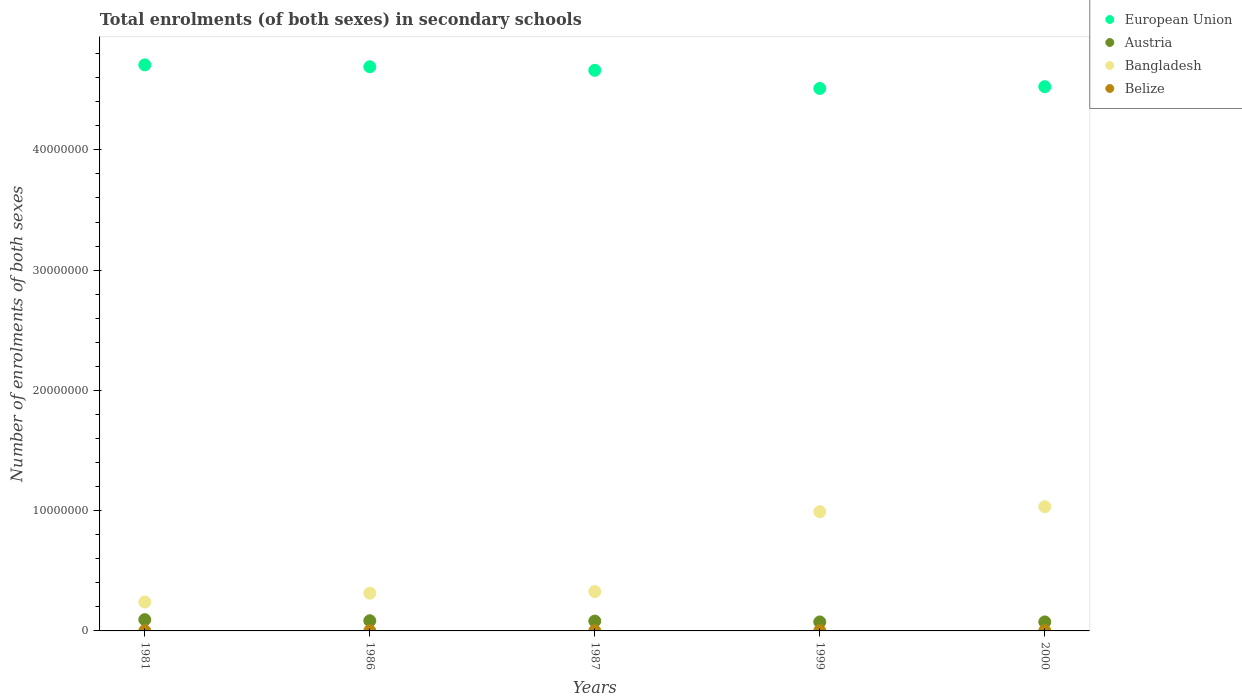How many different coloured dotlines are there?
Provide a short and direct response. 4. Is the number of dotlines equal to the number of legend labels?
Provide a succinct answer. Yes. What is the number of enrolments in secondary schools in Austria in 1987?
Offer a very short reply. 8.19e+05. Across all years, what is the maximum number of enrolments in secondary schools in Belize?
Give a very brief answer. 2.32e+04. Across all years, what is the minimum number of enrolments in secondary schools in Austria?
Offer a very short reply. 7.48e+05. In which year was the number of enrolments in secondary schools in Bangladesh maximum?
Offer a terse response. 2000. In which year was the number of enrolments in secondary schools in Belize minimum?
Your answer should be very brief. 1981. What is the total number of enrolments in secondary schools in Belize in the graph?
Your response must be concise. 8.73e+04. What is the difference between the number of enrolments in secondary schools in European Union in 1986 and that in 1999?
Keep it short and to the point. 1.80e+06. What is the difference between the number of enrolments in secondary schools in Belize in 1999 and the number of enrolments in secondary schools in Austria in 2000?
Ensure brevity in your answer.  -7.27e+05. What is the average number of enrolments in secondary schools in Bangladesh per year?
Provide a succinct answer. 5.81e+06. In the year 2000, what is the difference between the number of enrolments in secondary schools in Bangladesh and number of enrolments in secondary schools in Austria?
Offer a very short reply. 9.58e+06. What is the ratio of the number of enrolments in secondary schools in Austria in 1981 to that in 1999?
Offer a terse response. 1.25. Is the number of enrolments in secondary schools in Belize in 1981 less than that in 1986?
Give a very brief answer. Yes. What is the difference between the highest and the second highest number of enrolments in secondary schools in European Union?
Provide a short and direct response. 1.57e+05. What is the difference between the highest and the lowest number of enrolments in secondary schools in Belize?
Offer a terse response. 1.10e+04. Is the sum of the number of enrolments in secondary schools in European Union in 1987 and 2000 greater than the maximum number of enrolments in secondary schools in Bangladesh across all years?
Your answer should be compact. Yes. Does the number of enrolments in secondary schools in Belize monotonically increase over the years?
Provide a succinct answer. Yes. Is the number of enrolments in secondary schools in Bangladesh strictly less than the number of enrolments in secondary schools in European Union over the years?
Make the answer very short. Yes. How many years are there in the graph?
Offer a terse response. 5. What is the difference between two consecutive major ticks on the Y-axis?
Offer a very short reply. 1.00e+07. Does the graph contain any zero values?
Offer a terse response. No. Does the graph contain grids?
Make the answer very short. No. How are the legend labels stacked?
Offer a terse response. Vertical. What is the title of the graph?
Make the answer very short. Total enrolments (of both sexes) in secondary schools. What is the label or title of the X-axis?
Offer a terse response. Years. What is the label or title of the Y-axis?
Give a very brief answer. Number of enrolments of both sexes. What is the Number of enrolments of both sexes in European Union in 1981?
Provide a succinct answer. 4.71e+07. What is the Number of enrolments of both sexes in Austria in 1981?
Your answer should be very brief. 9.37e+05. What is the Number of enrolments of both sexes of Bangladesh in 1981?
Offer a very short reply. 2.41e+06. What is the Number of enrolments of both sexes of Belize in 1981?
Your response must be concise. 1.22e+04. What is the Number of enrolments of both sexes in European Union in 1986?
Ensure brevity in your answer.  4.69e+07. What is the Number of enrolments of both sexes in Austria in 1986?
Ensure brevity in your answer.  8.47e+05. What is the Number of enrolments of both sexes of Bangladesh in 1986?
Provide a short and direct response. 3.14e+06. What is the Number of enrolments of both sexes in Belize in 1986?
Your answer should be very brief. 1.46e+04. What is the Number of enrolments of both sexes of European Union in 1987?
Keep it short and to the point. 4.66e+07. What is the Number of enrolments of both sexes of Austria in 1987?
Keep it short and to the point. 8.19e+05. What is the Number of enrolments of both sexes of Bangladesh in 1987?
Offer a terse response. 3.27e+06. What is the Number of enrolments of both sexes in Belize in 1987?
Provide a short and direct response. 1.55e+04. What is the Number of enrolments of both sexes in European Union in 1999?
Your answer should be compact. 4.51e+07. What is the Number of enrolments of both sexes in Austria in 1999?
Offer a terse response. 7.48e+05. What is the Number of enrolments of both sexes of Bangladesh in 1999?
Provide a succinct answer. 9.91e+06. What is the Number of enrolments of both sexes in Belize in 1999?
Your response must be concise. 2.17e+04. What is the Number of enrolments of both sexes of European Union in 2000?
Provide a succinct answer. 4.53e+07. What is the Number of enrolments of both sexes in Austria in 2000?
Your response must be concise. 7.49e+05. What is the Number of enrolments of both sexes in Bangladesh in 2000?
Offer a very short reply. 1.03e+07. What is the Number of enrolments of both sexes of Belize in 2000?
Offer a very short reply. 2.32e+04. Across all years, what is the maximum Number of enrolments of both sexes of European Union?
Provide a succinct answer. 4.71e+07. Across all years, what is the maximum Number of enrolments of both sexes of Austria?
Ensure brevity in your answer.  9.37e+05. Across all years, what is the maximum Number of enrolments of both sexes of Bangladesh?
Offer a very short reply. 1.03e+07. Across all years, what is the maximum Number of enrolments of both sexes in Belize?
Offer a very short reply. 2.32e+04. Across all years, what is the minimum Number of enrolments of both sexes of European Union?
Your answer should be very brief. 4.51e+07. Across all years, what is the minimum Number of enrolments of both sexes in Austria?
Your answer should be compact. 7.48e+05. Across all years, what is the minimum Number of enrolments of both sexes of Bangladesh?
Provide a succinct answer. 2.41e+06. Across all years, what is the minimum Number of enrolments of both sexes in Belize?
Ensure brevity in your answer.  1.22e+04. What is the total Number of enrolments of both sexes of European Union in the graph?
Provide a short and direct response. 2.31e+08. What is the total Number of enrolments of both sexes of Austria in the graph?
Keep it short and to the point. 4.10e+06. What is the total Number of enrolments of both sexes of Bangladesh in the graph?
Provide a succinct answer. 2.91e+07. What is the total Number of enrolments of both sexes in Belize in the graph?
Offer a very short reply. 8.73e+04. What is the difference between the Number of enrolments of both sexes of European Union in 1981 and that in 1986?
Provide a succinct answer. 1.57e+05. What is the difference between the Number of enrolments of both sexes of Austria in 1981 and that in 1986?
Keep it short and to the point. 9.03e+04. What is the difference between the Number of enrolments of both sexes of Bangladesh in 1981 and that in 1986?
Ensure brevity in your answer.  -7.29e+05. What is the difference between the Number of enrolments of both sexes in Belize in 1981 and that in 1986?
Keep it short and to the point. -2399. What is the difference between the Number of enrolments of both sexes of European Union in 1981 and that in 1987?
Offer a terse response. 4.52e+05. What is the difference between the Number of enrolments of both sexes of Austria in 1981 and that in 1987?
Provide a short and direct response. 1.19e+05. What is the difference between the Number of enrolments of both sexes in Bangladesh in 1981 and that in 1987?
Your response must be concise. -8.65e+05. What is the difference between the Number of enrolments of both sexes in Belize in 1981 and that in 1987?
Keep it short and to the point. -3257. What is the difference between the Number of enrolments of both sexes of European Union in 1981 and that in 1999?
Keep it short and to the point. 1.96e+06. What is the difference between the Number of enrolments of both sexes in Austria in 1981 and that in 1999?
Your response must be concise. 1.90e+05. What is the difference between the Number of enrolments of both sexes in Bangladesh in 1981 and that in 1999?
Provide a succinct answer. -7.50e+06. What is the difference between the Number of enrolments of both sexes of Belize in 1981 and that in 1999?
Offer a terse response. -9411. What is the difference between the Number of enrolments of both sexes of European Union in 1981 and that in 2000?
Provide a succinct answer. 1.81e+06. What is the difference between the Number of enrolments of both sexes of Austria in 1981 and that in 2000?
Give a very brief answer. 1.89e+05. What is the difference between the Number of enrolments of both sexes of Bangladesh in 1981 and that in 2000?
Your answer should be very brief. -7.92e+06. What is the difference between the Number of enrolments of both sexes in Belize in 1981 and that in 2000?
Ensure brevity in your answer.  -1.10e+04. What is the difference between the Number of enrolments of both sexes of European Union in 1986 and that in 1987?
Make the answer very short. 2.95e+05. What is the difference between the Number of enrolments of both sexes of Austria in 1986 and that in 1987?
Your response must be concise. 2.83e+04. What is the difference between the Number of enrolments of both sexes in Bangladesh in 1986 and that in 1987?
Keep it short and to the point. -1.36e+05. What is the difference between the Number of enrolments of both sexes of Belize in 1986 and that in 1987?
Provide a short and direct response. -858. What is the difference between the Number of enrolments of both sexes of European Union in 1986 and that in 1999?
Your answer should be compact. 1.80e+06. What is the difference between the Number of enrolments of both sexes in Austria in 1986 and that in 1999?
Provide a short and direct response. 9.95e+04. What is the difference between the Number of enrolments of both sexes of Bangladesh in 1986 and that in 1999?
Your answer should be very brief. -6.78e+06. What is the difference between the Number of enrolments of both sexes of Belize in 1986 and that in 1999?
Give a very brief answer. -7012. What is the difference between the Number of enrolments of both sexes of European Union in 1986 and that in 2000?
Your answer should be compact. 1.66e+06. What is the difference between the Number of enrolments of both sexes in Austria in 1986 and that in 2000?
Provide a short and direct response. 9.85e+04. What is the difference between the Number of enrolments of both sexes of Bangladesh in 1986 and that in 2000?
Offer a terse response. -7.19e+06. What is the difference between the Number of enrolments of both sexes of Belize in 1986 and that in 2000?
Your response must be concise. -8588. What is the difference between the Number of enrolments of both sexes in European Union in 1987 and that in 1999?
Offer a terse response. 1.51e+06. What is the difference between the Number of enrolments of both sexes in Austria in 1987 and that in 1999?
Your response must be concise. 7.12e+04. What is the difference between the Number of enrolments of both sexes in Bangladesh in 1987 and that in 1999?
Give a very brief answer. -6.64e+06. What is the difference between the Number of enrolments of both sexes in Belize in 1987 and that in 1999?
Make the answer very short. -6154. What is the difference between the Number of enrolments of both sexes of European Union in 1987 and that in 2000?
Your answer should be very brief. 1.36e+06. What is the difference between the Number of enrolments of both sexes of Austria in 1987 and that in 2000?
Your answer should be very brief. 7.02e+04. What is the difference between the Number of enrolments of both sexes of Bangladesh in 1987 and that in 2000?
Your answer should be compact. -7.06e+06. What is the difference between the Number of enrolments of both sexes of Belize in 1987 and that in 2000?
Your answer should be compact. -7730. What is the difference between the Number of enrolments of both sexes in European Union in 1999 and that in 2000?
Ensure brevity in your answer.  -1.47e+05. What is the difference between the Number of enrolments of both sexes of Austria in 1999 and that in 2000?
Offer a terse response. -978. What is the difference between the Number of enrolments of both sexes in Bangladesh in 1999 and that in 2000?
Make the answer very short. -4.17e+05. What is the difference between the Number of enrolments of both sexes in Belize in 1999 and that in 2000?
Offer a very short reply. -1576. What is the difference between the Number of enrolments of both sexes in European Union in 1981 and the Number of enrolments of both sexes in Austria in 1986?
Make the answer very short. 4.62e+07. What is the difference between the Number of enrolments of both sexes of European Union in 1981 and the Number of enrolments of both sexes of Bangladesh in 1986?
Your answer should be compact. 4.39e+07. What is the difference between the Number of enrolments of both sexes in European Union in 1981 and the Number of enrolments of both sexes in Belize in 1986?
Provide a succinct answer. 4.71e+07. What is the difference between the Number of enrolments of both sexes in Austria in 1981 and the Number of enrolments of both sexes in Bangladesh in 1986?
Your answer should be compact. -2.20e+06. What is the difference between the Number of enrolments of both sexes in Austria in 1981 and the Number of enrolments of both sexes in Belize in 1986?
Provide a short and direct response. 9.23e+05. What is the difference between the Number of enrolments of both sexes in Bangladesh in 1981 and the Number of enrolments of both sexes in Belize in 1986?
Your answer should be very brief. 2.39e+06. What is the difference between the Number of enrolments of both sexes of European Union in 1981 and the Number of enrolments of both sexes of Austria in 1987?
Offer a very short reply. 4.63e+07. What is the difference between the Number of enrolments of both sexes in European Union in 1981 and the Number of enrolments of both sexes in Bangladesh in 1987?
Keep it short and to the point. 4.38e+07. What is the difference between the Number of enrolments of both sexes in European Union in 1981 and the Number of enrolments of both sexes in Belize in 1987?
Offer a terse response. 4.71e+07. What is the difference between the Number of enrolments of both sexes in Austria in 1981 and the Number of enrolments of both sexes in Bangladesh in 1987?
Offer a terse response. -2.34e+06. What is the difference between the Number of enrolments of both sexes of Austria in 1981 and the Number of enrolments of both sexes of Belize in 1987?
Your response must be concise. 9.22e+05. What is the difference between the Number of enrolments of both sexes of Bangladesh in 1981 and the Number of enrolments of both sexes of Belize in 1987?
Provide a short and direct response. 2.39e+06. What is the difference between the Number of enrolments of both sexes in European Union in 1981 and the Number of enrolments of both sexes in Austria in 1999?
Your answer should be compact. 4.63e+07. What is the difference between the Number of enrolments of both sexes in European Union in 1981 and the Number of enrolments of both sexes in Bangladesh in 1999?
Your response must be concise. 3.72e+07. What is the difference between the Number of enrolments of both sexes in European Union in 1981 and the Number of enrolments of both sexes in Belize in 1999?
Your answer should be compact. 4.70e+07. What is the difference between the Number of enrolments of both sexes in Austria in 1981 and the Number of enrolments of both sexes in Bangladesh in 1999?
Your answer should be very brief. -8.97e+06. What is the difference between the Number of enrolments of both sexes in Austria in 1981 and the Number of enrolments of both sexes in Belize in 1999?
Offer a very short reply. 9.16e+05. What is the difference between the Number of enrolments of both sexes of Bangladesh in 1981 and the Number of enrolments of both sexes of Belize in 1999?
Your response must be concise. 2.39e+06. What is the difference between the Number of enrolments of both sexes in European Union in 1981 and the Number of enrolments of both sexes in Austria in 2000?
Provide a succinct answer. 4.63e+07. What is the difference between the Number of enrolments of both sexes in European Union in 1981 and the Number of enrolments of both sexes in Bangladesh in 2000?
Give a very brief answer. 3.67e+07. What is the difference between the Number of enrolments of both sexes of European Union in 1981 and the Number of enrolments of both sexes of Belize in 2000?
Ensure brevity in your answer.  4.70e+07. What is the difference between the Number of enrolments of both sexes in Austria in 1981 and the Number of enrolments of both sexes in Bangladesh in 2000?
Your response must be concise. -9.39e+06. What is the difference between the Number of enrolments of both sexes in Austria in 1981 and the Number of enrolments of both sexes in Belize in 2000?
Your answer should be compact. 9.14e+05. What is the difference between the Number of enrolments of both sexes in Bangladesh in 1981 and the Number of enrolments of both sexes in Belize in 2000?
Offer a very short reply. 2.38e+06. What is the difference between the Number of enrolments of both sexes of European Union in 1986 and the Number of enrolments of both sexes of Austria in 1987?
Give a very brief answer. 4.61e+07. What is the difference between the Number of enrolments of both sexes of European Union in 1986 and the Number of enrolments of both sexes of Bangladesh in 1987?
Your answer should be very brief. 4.36e+07. What is the difference between the Number of enrolments of both sexes of European Union in 1986 and the Number of enrolments of both sexes of Belize in 1987?
Your response must be concise. 4.69e+07. What is the difference between the Number of enrolments of both sexes of Austria in 1986 and the Number of enrolments of both sexes of Bangladesh in 1987?
Provide a succinct answer. -2.43e+06. What is the difference between the Number of enrolments of both sexes in Austria in 1986 and the Number of enrolments of both sexes in Belize in 1987?
Your answer should be compact. 8.32e+05. What is the difference between the Number of enrolments of both sexes in Bangladesh in 1986 and the Number of enrolments of both sexes in Belize in 1987?
Your answer should be compact. 3.12e+06. What is the difference between the Number of enrolments of both sexes in European Union in 1986 and the Number of enrolments of both sexes in Austria in 1999?
Ensure brevity in your answer.  4.62e+07. What is the difference between the Number of enrolments of both sexes of European Union in 1986 and the Number of enrolments of both sexes of Bangladesh in 1999?
Ensure brevity in your answer.  3.70e+07. What is the difference between the Number of enrolments of both sexes in European Union in 1986 and the Number of enrolments of both sexes in Belize in 1999?
Your answer should be very brief. 4.69e+07. What is the difference between the Number of enrolments of both sexes of Austria in 1986 and the Number of enrolments of both sexes of Bangladesh in 1999?
Your answer should be very brief. -9.07e+06. What is the difference between the Number of enrolments of both sexes of Austria in 1986 and the Number of enrolments of both sexes of Belize in 1999?
Offer a very short reply. 8.26e+05. What is the difference between the Number of enrolments of both sexes in Bangladesh in 1986 and the Number of enrolments of both sexes in Belize in 1999?
Ensure brevity in your answer.  3.11e+06. What is the difference between the Number of enrolments of both sexes in European Union in 1986 and the Number of enrolments of both sexes in Austria in 2000?
Give a very brief answer. 4.62e+07. What is the difference between the Number of enrolments of both sexes in European Union in 1986 and the Number of enrolments of both sexes in Bangladesh in 2000?
Provide a short and direct response. 3.66e+07. What is the difference between the Number of enrolments of both sexes of European Union in 1986 and the Number of enrolments of both sexes of Belize in 2000?
Keep it short and to the point. 4.69e+07. What is the difference between the Number of enrolments of both sexes in Austria in 1986 and the Number of enrolments of both sexes in Bangladesh in 2000?
Your response must be concise. -9.48e+06. What is the difference between the Number of enrolments of both sexes of Austria in 1986 and the Number of enrolments of both sexes of Belize in 2000?
Make the answer very short. 8.24e+05. What is the difference between the Number of enrolments of both sexes in Bangladesh in 1986 and the Number of enrolments of both sexes in Belize in 2000?
Offer a very short reply. 3.11e+06. What is the difference between the Number of enrolments of both sexes of European Union in 1987 and the Number of enrolments of both sexes of Austria in 1999?
Provide a succinct answer. 4.59e+07. What is the difference between the Number of enrolments of both sexes in European Union in 1987 and the Number of enrolments of both sexes in Bangladesh in 1999?
Your response must be concise. 3.67e+07. What is the difference between the Number of enrolments of both sexes of European Union in 1987 and the Number of enrolments of both sexes of Belize in 1999?
Give a very brief answer. 4.66e+07. What is the difference between the Number of enrolments of both sexes in Austria in 1987 and the Number of enrolments of both sexes in Bangladesh in 1999?
Your response must be concise. -9.09e+06. What is the difference between the Number of enrolments of both sexes of Austria in 1987 and the Number of enrolments of both sexes of Belize in 1999?
Give a very brief answer. 7.97e+05. What is the difference between the Number of enrolments of both sexes in Bangladesh in 1987 and the Number of enrolments of both sexes in Belize in 1999?
Your response must be concise. 3.25e+06. What is the difference between the Number of enrolments of both sexes of European Union in 1987 and the Number of enrolments of both sexes of Austria in 2000?
Provide a short and direct response. 4.59e+07. What is the difference between the Number of enrolments of both sexes in European Union in 1987 and the Number of enrolments of both sexes in Bangladesh in 2000?
Give a very brief answer. 3.63e+07. What is the difference between the Number of enrolments of both sexes in European Union in 1987 and the Number of enrolments of both sexes in Belize in 2000?
Make the answer very short. 4.66e+07. What is the difference between the Number of enrolments of both sexes in Austria in 1987 and the Number of enrolments of both sexes in Bangladesh in 2000?
Your response must be concise. -9.51e+06. What is the difference between the Number of enrolments of both sexes of Austria in 1987 and the Number of enrolments of both sexes of Belize in 2000?
Your answer should be compact. 7.96e+05. What is the difference between the Number of enrolments of both sexes of Bangladesh in 1987 and the Number of enrolments of both sexes of Belize in 2000?
Provide a short and direct response. 3.25e+06. What is the difference between the Number of enrolments of both sexes of European Union in 1999 and the Number of enrolments of both sexes of Austria in 2000?
Offer a terse response. 4.44e+07. What is the difference between the Number of enrolments of both sexes in European Union in 1999 and the Number of enrolments of both sexes in Bangladesh in 2000?
Your answer should be very brief. 3.48e+07. What is the difference between the Number of enrolments of both sexes in European Union in 1999 and the Number of enrolments of both sexes in Belize in 2000?
Make the answer very short. 4.51e+07. What is the difference between the Number of enrolments of both sexes of Austria in 1999 and the Number of enrolments of both sexes of Bangladesh in 2000?
Your answer should be very brief. -9.58e+06. What is the difference between the Number of enrolments of both sexes of Austria in 1999 and the Number of enrolments of both sexes of Belize in 2000?
Provide a succinct answer. 7.24e+05. What is the difference between the Number of enrolments of both sexes of Bangladesh in 1999 and the Number of enrolments of both sexes of Belize in 2000?
Give a very brief answer. 9.89e+06. What is the average Number of enrolments of both sexes in European Union per year?
Ensure brevity in your answer.  4.62e+07. What is the average Number of enrolments of both sexes in Austria per year?
Keep it short and to the point. 8.20e+05. What is the average Number of enrolments of both sexes of Bangladesh per year?
Your answer should be very brief. 5.81e+06. What is the average Number of enrolments of both sexes of Belize per year?
Keep it short and to the point. 1.75e+04. In the year 1981, what is the difference between the Number of enrolments of both sexes in European Union and Number of enrolments of both sexes in Austria?
Provide a short and direct response. 4.61e+07. In the year 1981, what is the difference between the Number of enrolments of both sexes in European Union and Number of enrolments of both sexes in Bangladesh?
Keep it short and to the point. 4.47e+07. In the year 1981, what is the difference between the Number of enrolments of both sexes of European Union and Number of enrolments of both sexes of Belize?
Your response must be concise. 4.71e+07. In the year 1981, what is the difference between the Number of enrolments of both sexes in Austria and Number of enrolments of both sexes in Bangladesh?
Keep it short and to the point. -1.47e+06. In the year 1981, what is the difference between the Number of enrolments of both sexes in Austria and Number of enrolments of both sexes in Belize?
Offer a very short reply. 9.25e+05. In the year 1981, what is the difference between the Number of enrolments of both sexes of Bangladesh and Number of enrolments of both sexes of Belize?
Your response must be concise. 2.40e+06. In the year 1986, what is the difference between the Number of enrolments of both sexes of European Union and Number of enrolments of both sexes of Austria?
Your answer should be compact. 4.61e+07. In the year 1986, what is the difference between the Number of enrolments of both sexes of European Union and Number of enrolments of both sexes of Bangladesh?
Offer a very short reply. 4.38e+07. In the year 1986, what is the difference between the Number of enrolments of both sexes in European Union and Number of enrolments of both sexes in Belize?
Offer a terse response. 4.69e+07. In the year 1986, what is the difference between the Number of enrolments of both sexes in Austria and Number of enrolments of both sexes in Bangladesh?
Ensure brevity in your answer.  -2.29e+06. In the year 1986, what is the difference between the Number of enrolments of both sexes in Austria and Number of enrolments of both sexes in Belize?
Offer a terse response. 8.33e+05. In the year 1986, what is the difference between the Number of enrolments of both sexes in Bangladesh and Number of enrolments of both sexes in Belize?
Make the answer very short. 3.12e+06. In the year 1987, what is the difference between the Number of enrolments of both sexes in European Union and Number of enrolments of both sexes in Austria?
Your response must be concise. 4.58e+07. In the year 1987, what is the difference between the Number of enrolments of both sexes of European Union and Number of enrolments of both sexes of Bangladesh?
Ensure brevity in your answer.  4.33e+07. In the year 1987, what is the difference between the Number of enrolments of both sexes in European Union and Number of enrolments of both sexes in Belize?
Your response must be concise. 4.66e+07. In the year 1987, what is the difference between the Number of enrolments of both sexes in Austria and Number of enrolments of both sexes in Bangladesh?
Offer a very short reply. -2.45e+06. In the year 1987, what is the difference between the Number of enrolments of both sexes in Austria and Number of enrolments of both sexes in Belize?
Your answer should be very brief. 8.03e+05. In the year 1987, what is the difference between the Number of enrolments of both sexes in Bangladesh and Number of enrolments of both sexes in Belize?
Your answer should be compact. 3.26e+06. In the year 1999, what is the difference between the Number of enrolments of both sexes in European Union and Number of enrolments of both sexes in Austria?
Give a very brief answer. 4.44e+07. In the year 1999, what is the difference between the Number of enrolments of both sexes of European Union and Number of enrolments of both sexes of Bangladesh?
Offer a terse response. 3.52e+07. In the year 1999, what is the difference between the Number of enrolments of both sexes of European Union and Number of enrolments of both sexes of Belize?
Offer a terse response. 4.51e+07. In the year 1999, what is the difference between the Number of enrolments of both sexes in Austria and Number of enrolments of both sexes in Bangladesh?
Provide a short and direct response. -9.16e+06. In the year 1999, what is the difference between the Number of enrolments of both sexes of Austria and Number of enrolments of both sexes of Belize?
Offer a terse response. 7.26e+05. In the year 1999, what is the difference between the Number of enrolments of both sexes in Bangladesh and Number of enrolments of both sexes in Belize?
Make the answer very short. 9.89e+06. In the year 2000, what is the difference between the Number of enrolments of both sexes of European Union and Number of enrolments of both sexes of Austria?
Provide a succinct answer. 4.45e+07. In the year 2000, what is the difference between the Number of enrolments of both sexes of European Union and Number of enrolments of both sexes of Bangladesh?
Offer a terse response. 3.49e+07. In the year 2000, what is the difference between the Number of enrolments of both sexes of European Union and Number of enrolments of both sexes of Belize?
Offer a very short reply. 4.52e+07. In the year 2000, what is the difference between the Number of enrolments of both sexes of Austria and Number of enrolments of both sexes of Bangladesh?
Provide a succinct answer. -9.58e+06. In the year 2000, what is the difference between the Number of enrolments of both sexes of Austria and Number of enrolments of both sexes of Belize?
Ensure brevity in your answer.  7.25e+05. In the year 2000, what is the difference between the Number of enrolments of both sexes in Bangladesh and Number of enrolments of both sexes in Belize?
Give a very brief answer. 1.03e+07. What is the ratio of the Number of enrolments of both sexes of Austria in 1981 to that in 1986?
Your answer should be compact. 1.11. What is the ratio of the Number of enrolments of both sexes of Bangladesh in 1981 to that in 1986?
Offer a terse response. 0.77. What is the ratio of the Number of enrolments of both sexes in Belize in 1981 to that in 1986?
Your answer should be compact. 0.84. What is the ratio of the Number of enrolments of both sexes of European Union in 1981 to that in 1987?
Make the answer very short. 1.01. What is the ratio of the Number of enrolments of both sexes in Austria in 1981 to that in 1987?
Provide a succinct answer. 1.14. What is the ratio of the Number of enrolments of both sexes in Bangladesh in 1981 to that in 1987?
Give a very brief answer. 0.74. What is the ratio of the Number of enrolments of both sexes of Belize in 1981 to that in 1987?
Keep it short and to the point. 0.79. What is the ratio of the Number of enrolments of both sexes in European Union in 1981 to that in 1999?
Provide a succinct answer. 1.04. What is the ratio of the Number of enrolments of both sexes of Austria in 1981 to that in 1999?
Your answer should be compact. 1.25. What is the ratio of the Number of enrolments of both sexes of Bangladesh in 1981 to that in 1999?
Make the answer very short. 0.24. What is the ratio of the Number of enrolments of both sexes in Belize in 1981 to that in 1999?
Offer a terse response. 0.57. What is the ratio of the Number of enrolments of both sexes in European Union in 1981 to that in 2000?
Offer a terse response. 1.04. What is the ratio of the Number of enrolments of both sexes of Austria in 1981 to that in 2000?
Make the answer very short. 1.25. What is the ratio of the Number of enrolments of both sexes of Bangladesh in 1981 to that in 2000?
Offer a terse response. 0.23. What is the ratio of the Number of enrolments of both sexes in Belize in 1981 to that in 2000?
Your response must be concise. 0.53. What is the ratio of the Number of enrolments of both sexes of European Union in 1986 to that in 1987?
Your answer should be very brief. 1.01. What is the ratio of the Number of enrolments of both sexes in Austria in 1986 to that in 1987?
Your response must be concise. 1.03. What is the ratio of the Number of enrolments of both sexes of Bangladesh in 1986 to that in 1987?
Keep it short and to the point. 0.96. What is the ratio of the Number of enrolments of both sexes in Belize in 1986 to that in 1987?
Offer a terse response. 0.94. What is the ratio of the Number of enrolments of both sexes of European Union in 1986 to that in 1999?
Offer a terse response. 1.04. What is the ratio of the Number of enrolments of both sexes of Austria in 1986 to that in 1999?
Ensure brevity in your answer.  1.13. What is the ratio of the Number of enrolments of both sexes of Bangladesh in 1986 to that in 1999?
Offer a terse response. 0.32. What is the ratio of the Number of enrolments of both sexes in Belize in 1986 to that in 1999?
Keep it short and to the point. 0.68. What is the ratio of the Number of enrolments of both sexes of European Union in 1986 to that in 2000?
Your response must be concise. 1.04. What is the ratio of the Number of enrolments of both sexes of Austria in 1986 to that in 2000?
Ensure brevity in your answer.  1.13. What is the ratio of the Number of enrolments of both sexes in Bangladesh in 1986 to that in 2000?
Ensure brevity in your answer.  0.3. What is the ratio of the Number of enrolments of both sexes of Belize in 1986 to that in 2000?
Give a very brief answer. 0.63. What is the ratio of the Number of enrolments of both sexes in European Union in 1987 to that in 1999?
Your answer should be compact. 1.03. What is the ratio of the Number of enrolments of both sexes of Austria in 1987 to that in 1999?
Offer a terse response. 1.1. What is the ratio of the Number of enrolments of both sexes of Bangladesh in 1987 to that in 1999?
Offer a terse response. 0.33. What is the ratio of the Number of enrolments of both sexes in Belize in 1987 to that in 1999?
Your answer should be compact. 0.72. What is the ratio of the Number of enrolments of both sexes of European Union in 1987 to that in 2000?
Make the answer very short. 1.03. What is the ratio of the Number of enrolments of both sexes in Austria in 1987 to that in 2000?
Offer a very short reply. 1.09. What is the ratio of the Number of enrolments of both sexes in Bangladesh in 1987 to that in 2000?
Your answer should be very brief. 0.32. What is the ratio of the Number of enrolments of both sexes of Belize in 1987 to that in 2000?
Offer a very short reply. 0.67. What is the ratio of the Number of enrolments of both sexes of European Union in 1999 to that in 2000?
Make the answer very short. 1. What is the ratio of the Number of enrolments of both sexes of Austria in 1999 to that in 2000?
Provide a short and direct response. 1. What is the ratio of the Number of enrolments of both sexes of Bangladesh in 1999 to that in 2000?
Keep it short and to the point. 0.96. What is the ratio of the Number of enrolments of both sexes of Belize in 1999 to that in 2000?
Provide a short and direct response. 0.93. What is the difference between the highest and the second highest Number of enrolments of both sexes of European Union?
Your answer should be compact. 1.57e+05. What is the difference between the highest and the second highest Number of enrolments of both sexes of Austria?
Provide a succinct answer. 9.03e+04. What is the difference between the highest and the second highest Number of enrolments of both sexes in Bangladesh?
Offer a terse response. 4.17e+05. What is the difference between the highest and the second highest Number of enrolments of both sexes in Belize?
Your answer should be very brief. 1576. What is the difference between the highest and the lowest Number of enrolments of both sexes of European Union?
Provide a succinct answer. 1.96e+06. What is the difference between the highest and the lowest Number of enrolments of both sexes of Austria?
Keep it short and to the point. 1.90e+05. What is the difference between the highest and the lowest Number of enrolments of both sexes of Bangladesh?
Keep it short and to the point. 7.92e+06. What is the difference between the highest and the lowest Number of enrolments of both sexes of Belize?
Offer a terse response. 1.10e+04. 